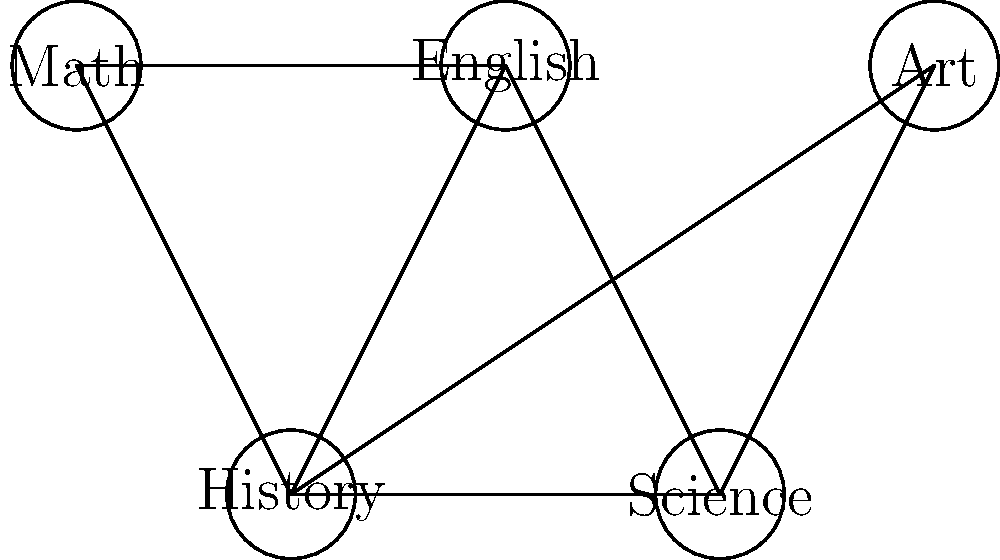In an attempt to optimize the class schedule at Leto High School to minimize conflicts, the administration has represented the problem as a graph coloring problem. The graph above shows five subjects: Math, English, History, Science, and Art. Connected subjects cannot be scheduled in the same time slot. What is the minimum number of time slots (colors) needed to schedule all these classes without conflicts? To solve this graph coloring problem, we'll follow these steps:

1) First, we need to understand what the graph represents:
   - Each node represents a subject
   - Each edge represents a conflict (connected subjects can't be in the same time slot)

2) Now, let's analyze the connections:
   - Math is connected to English, History, and Art
   - English is connected to Math, History, and Science
   - History is connected to Math, English, Science, and Art
   - Science is connected to English, History, and Art
   - Art is connected to Math, History, and Science

3) To color the graph (assign time slots), we start with the node with the most connections:
   - History has 4 connections, so we'll start there and give it color 1

4) Now we color the neighbors of History with different colors:
   - Math: color 2
   - English: color 3
   - Science: color 4
   - Art: color 2 (it can share a color with Math as they're not connected)

5) We've now used 4 colors (time slots) and all nodes are colored without conflicts

6) There's no way to use fewer than 4 colors because History has 4 connections, and each of its neighbors must have a different color from it and each other

Therefore, the minimum number of time slots needed is 4.
Answer: 4 time slots 